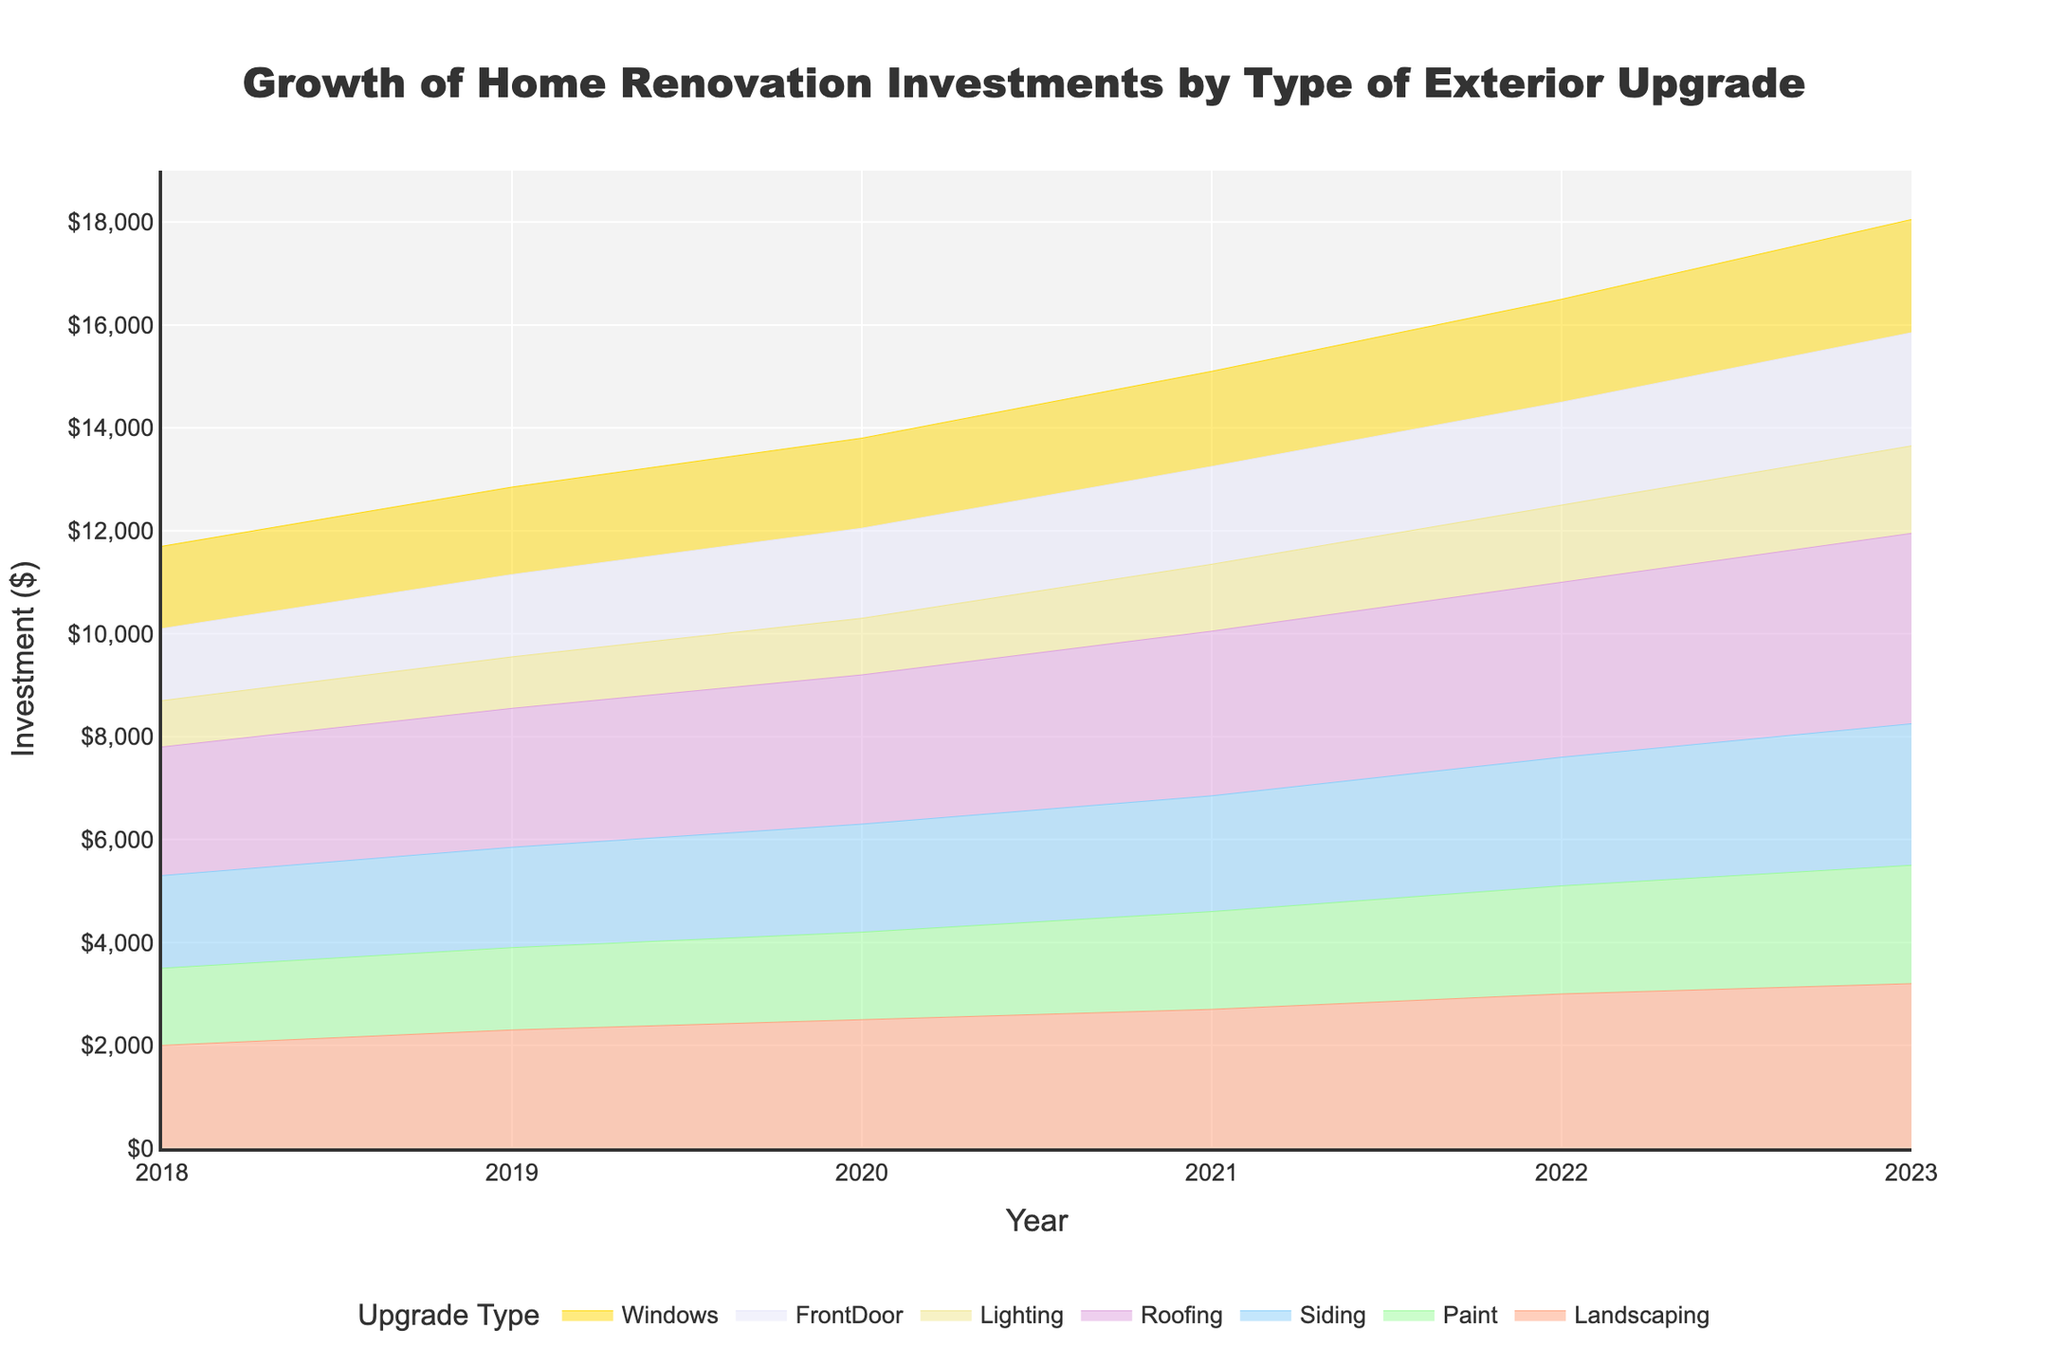What's the title of the figure? The title is usually displayed prominently at the top of the figure. In this case, we can see that the title is centered and reads "Growth of Home Renovation Investments by Type of Exterior Upgrade".
Answer: Growth of Home Renovation Investments by Type of Exterior Upgrade What are the different types of exterior upgrades shown in the figure? The types of exterior upgrades are listed in the legend and color-coded. They include Landscaping, Paint, Siding, Roofing, Lighting, Front Door, and Windows.
Answer: Landscaping, Paint, Siding, Roofing, Lighting, Front Door, Windows Which upgrade type had the highest investment in 2023? To determine this, we look at the area chart and identify the category with the highest value on the Y-axis for the year 2023.
Answer: Roofing How much did the investment in Landscaping increase from 2018 to 2023? We locate the values for Landscaping in 2018 and 2023. The difference between these two values (3200 - 2000) gives the increase.
Answer: 1200 Which two types of exterior upgrades saw the least investment in 2020? We compare the values for each category in 2020. The two lowest values are for Lighting and Front Door.
Answer: Lighting and Front Door What is the total investment in all exterior upgrades for the year 2022? We sum up the investments for all categories in 2022. (3000 + 2100 + 2500 + 3400 + 1500 + 2000 + 2000)
Answer: 16500 Between which two consecutive years did the investment in Windows see the greatest increase? We calculate the yearly increases for Windows and identify the largest one: 2018-2019 (1600 - 1400), 2019-2020 (1750 - 1600), 2020-2021 (1850 - 1750), 2021-2022 (2000 - 1850), 2022-2023 (2200 - 2000). The largest increase is 200.
Answer: 2021-2022 Which upgrade type shows the most consistent yearly growth over the displayed period? To determine consistency, we visually inspect each category's line and note that a linear, steady increase is most consistent. The category that fits this description best is Landscaping.
Answer: Landscaping Did investment in any upgrade type decrease in any year? We can look at each category's trend line. If a line dips between two years, it indicates a decrease. It's clear from the chart that no category experienced a decrease in investment from year to year.
Answer: No How did the investment trend for Paint change over time? We examine the Paint category's trend line from 2018 to 2023. The investment in Paint steadily increased over time without any drops.
Answer: Steady increase 